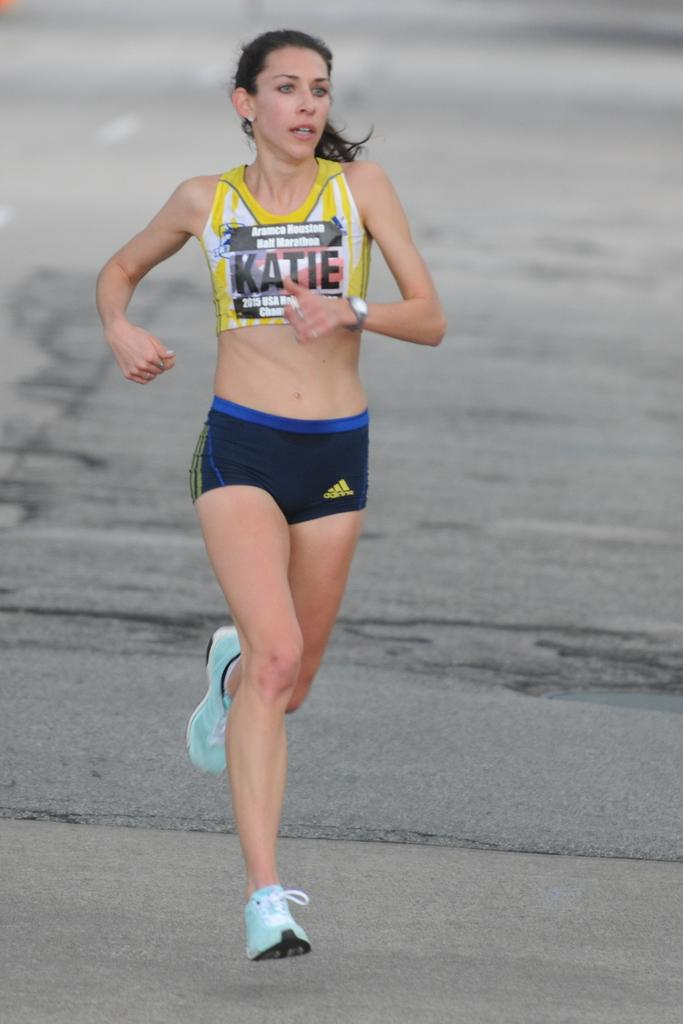<image>
Share a concise interpretation of the image provided. A woman athlete running on concrete for the Aramco Houston Half Marathon. 